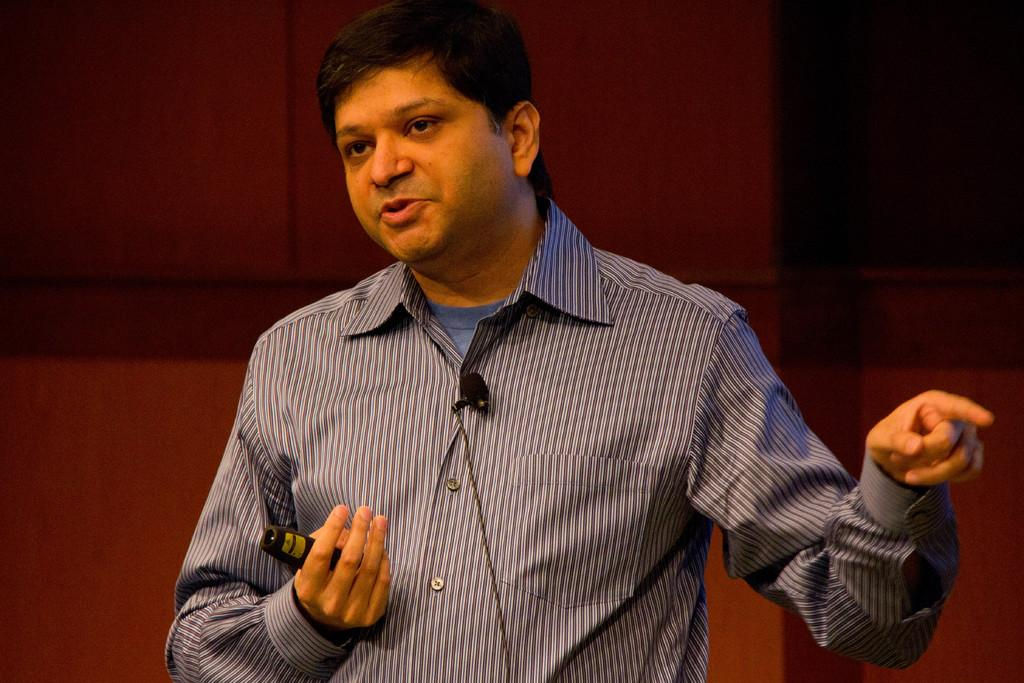What can be seen in the image? There is a person in the image. What is the person wearing? The person is wearing a blue shirt. What is the person holding? The person is holding something. What colors are present in the background of the image? The background of the image is maroon and black. How much profit did the pen generate in the image? There is no pen present in the image, so it is not possible to determine any profit generated. 